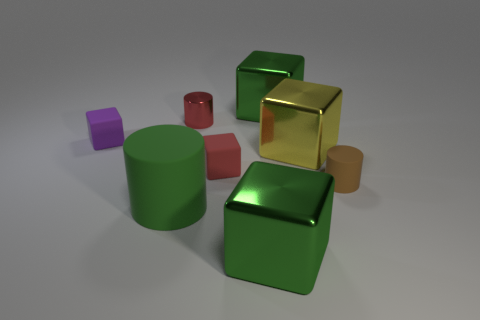Add 1 tiny brown cylinders. How many objects exist? 9 Subtract all rubber blocks. How many blocks are left? 3 Subtract all red cylinders. How many cylinders are left? 2 Subtract 1 red cylinders. How many objects are left? 7 Subtract all blocks. How many objects are left? 3 Subtract 1 cylinders. How many cylinders are left? 2 Subtract all red blocks. Subtract all gray cylinders. How many blocks are left? 4 Subtract all brown cylinders. How many cyan cubes are left? 0 Subtract all green metal things. Subtract all large yellow objects. How many objects are left? 5 Add 7 small matte cylinders. How many small matte cylinders are left? 8 